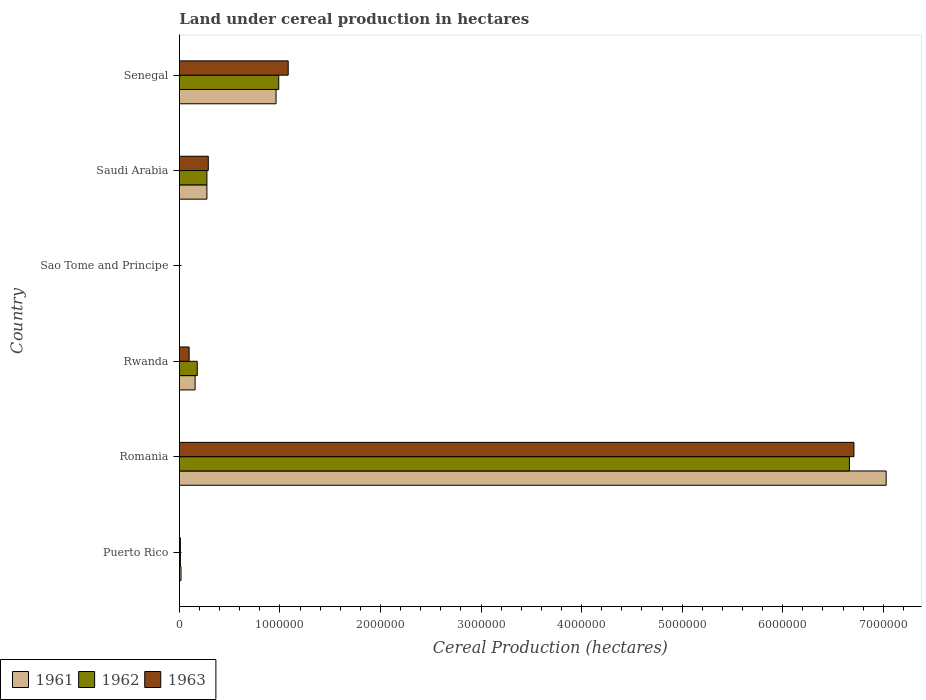Are the number of bars per tick equal to the number of legend labels?
Keep it short and to the point. Yes. What is the label of the 2nd group of bars from the top?
Make the answer very short. Saudi Arabia. What is the land under cereal production in 1962 in Puerto Rico?
Your response must be concise. 9489. Across all countries, what is the maximum land under cereal production in 1961?
Give a very brief answer. 7.03e+06. Across all countries, what is the minimum land under cereal production in 1962?
Provide a succinct answer. 270. In which country was the land under cereal production in 1963 maximum?
Your answer should be compact. Romania. In which country was the land under cereal production in 1961 minimum?
Provide a succinct answer. Sao Tome and Principe. What is the total land under cereal production in 1962 in the graph?
Keep it short and to the point. 8.11e+06. What is the difference between the land under cereal production in 1963 in Puerto Rico and that in Rwanda?
Provide a succinct answer. -8.71e+04. What is the difference between the land under cereal production in 1963 in Senegal and the land under cereal production in 1962 in Sao Tome and Principe?
Make the answer very short. 1.08e+06. What is the average land under cereal production in 1962 per country?
Your response must be concise. 1.35e+06. What is the difference between the land under cereal production in 1963 and land under cereal production in 1962 in Rwanda?
Your answer should be very brief. -8.09e+04. In how many countries, is the land under cereal production in 1963 greater than 6400000 hectares?
Offer a terse response. 1. What is the ratio of the land under cereal production in 1962 in Rwanda to that in Senegal?
Offer a terse response. 0.18. Is the difference between the land under cereal production in 1963 in Romania and Saudi Arabia greater than the difference between the land under cereal production in 1962 in Romania and Saudi Arabia?
Provide a short and direct response. Yes. What is the difference between the highest and the second highest land under cereal production in 1962?
Your response must be concise. 5.68e+06. What is the difference between the highest and the lowest land under cereal production in 1961?
Ensure brevity in your answer.  7.03e+06. What does the 2nd bar from the bottom in Saudi Arabia represents?
Offer a very short reply. 1962. How many bars are there?
Make the answer very short. 18. How many countries are there in the graph?
Offer a very short reply. 6. Does the graph contain any zero values?
Give a very brief answer. No. Where does the legend appear in the graph?
Keep it short and to the point. Bottom left. How are the legend labels stacked?
Your answer should be compact. Horizontal. What is the title of the graph?
Offer a very short reply. Land under cereal production in hectares. What is the label or title of the X-axis?
Keep it short and to the point. Cereal Production (hectares). What is the label or title of the Y-axis?
Your answer should be very brief. Country. What is the Cereal Production (hectares) of 1961 in Puerto Rico?
Make the answer very short. 1.59e+04. What is the Cereal Production (hectares) of 1962 in Puerto Rico?
Your answer should be very brief. 9489. What is the Cereal Production (hectares) in 1963 in Puerto Rico?
Your answer should be compact. 9519. What is the Cereal Production (hectares) in 1961 in Romania?
Provide a succinct answer. 7.03e+06. What is the Cereal Production (hectares) of 1962 in Romania?
Your answer should be very brief. 6.66e+06. What is the Cereal Production (hectares) in 1963 in Romania?
Keep it short and to the point. 6.71e+06. What is the Cereal Production (hectares) in 1961 in Rwanda?
Provide a short and direct response. 1.56e+05. What is the Cereal Production (hectares) in 1962 in Rwanda?
Ensure brevity in your answer.  1.78e+05. What is the Cereal Production (hectares) in 1963 in Rwanda?
Your answer should be compact. 9.66e+04. What is the Cereal Production (hectares) of 1961 in Sao Tome and Principe?
Offer a terse response. 270. What is the Cereal Production (hectares) in 1962 in Sao Tome and Principe?
Give a very brief answer. 270. What is the Cereal Production (hectares) of 1963 in Sao Tome and Principe?
Provide a short and direct response. 270. What is the Cereal Production (hectares) in 1961 in Saudi Arabia?
Make the answer very short. 2.74e+05. What is the Cereal Production (hectares) in 1962 in Saudi Arabia?
Your answer should be compact. 2.74e+05. What is the Cereal Production (hectares) in 1963 in Saudi Arabia?
Your response must be concise. 2.87e+05. What is the Cereal Production (hectares) in 1961 in Senegal?
Offer a very short reply. 9.61e+05. What is the Cereal Production (hectares) of 1962 in Senegal?
Your answer should be very brief. 9.88e+05. What is the Cereal Production (hectares) of 1963 in Senegal?
Provide a succinct answer. 1.08e+06. Across all countries, what is the maximum Cereal Production (hectares) of 1961?
Your response must be concise. 7.03e+06. Across all countries, what is the maximum Cereal Production (hectares) of 1962?
Keep it short and to the point. 6.66e+06. Across all countries, what is the maximum Cereal Production (hectares) of 1963?
Your answer should be very brief. 6.71e+06. Across all countries, what is the minimum Cereal Production (hectares) in 1961?
Offer a terse response. 270. Across all countries, what is the minimum Cereal Production (hectares) in 1962?
Keep it short and to the point. 270. Across all countries, what is the minimum Cereal Production (hectares) of 1963?
Provide a short and direct response. 270. What is the total Cereal Production (hectares) of 1961 in the graph?
Keep it short and to the point. 8.44e+06. What is the total Cereal Production (hectares) in 1962 in the graph?
Keep it short and to the point. 8.11e+06. What is the total Cereal Production (hectares) in 1963 in the graph?
Your response must be concise. 8.18e+06. What is the difference between the Cereal Production (hectares) of 1961 in Puerto Rico and that in Romania?
Ensure brevity in your answer.  -7.01e+06. What is the difference between the Cereal Production (hectares) in 1962 in Puerto Rico and that in Romania?
Your answer should be compact. -6.65e+06. What is the difference between the Cereal Production (hectares) of 1963 in Puerto Rico and that in Romania?
Keep it short and to the point. -6.70e+06. What is the difference between the Cereal Production (hectares) of 1961 in Puerto Rico and that in Rwanda?
Your answer should be very brief. -1.40e+05. What is the difference between the Cereal Production (hectares) of 1962 in Puerto Rico and that in Rwanda?
Offer a very short reply. -1.68e+05. What is the difference between the Cereal Production (hectares) of 1963 in Puerto Rico and that in Rwanda?
Keep it short and to the point. -8.71e+04. What is the difference between the Cereal Production (hectares) of 1961 in Puerto Rico and that in Sao Tome and Principe?
Keep it short and to the point. 1.56e+04. What is the difference between the Cereal Production (hectares) in 1962 in Puerto Rico and that in Sao Tome and Principe?
Ensure brevity in your answer.  9219. What is the difference between the Cereal Production (hectares) of 1963 in Puerto Rico and that in Sao Tome and Principe?
Your answer should be compact. 9249. What is the difference between the Cereal Production (hectares) in 1961 in Puerto Rico and that in Saudi Arabia?
Ensure brevity in your answer.  -2.58e+05. What is the difference between the Cereal Production (hectares) in 1962 in Puerto Rico and that in Saudi Arabia?
Provide a short and direct response. -2.64e+05. What is the difference between the Cereal Production (hectares) of 1963 in Puerto Rico and that in Saudi Arabia?
Offer a terse response. -2.78e+05. What is the difference between the Cereal Production (hectares) in 1961 in Puerto Rico and that in Senegal?
Make the answer very short. -9.45e+05. What is the difference between the Cereal Production (hectares) of 1962 in Puerto Rico and that in Senegal?
Keep it short and to the point. -9.79e+05. What is the difference between the Cereal Production (hectares) in 1963 in Puerto Rico and that in Senegal?
Give a very brief answer. -1.07e+06. What is the difference between the Cereal Production (hectares) of 1961 in Romania and that in Rwanda?
Keep it short and to the point. 6.87e+06. What is the difference between the Cereal Production (hectares) of 1962 in Romania and that in Rwanda?
Give a very brief answer. 6.49e+06. What is the difference between the Cereal Production (hectares) in 1963 in Romania and that in Rwanda?
Your answer should be compact. 6.61e+06. What is the difference between the Cereal Production (hectares) in 1961 in Romania and that in Sao Tome and Principe?
Ensure brevity in your answer.  7.03e+06. What is the difference between the Cereal Production (hectares) of 1962 in Romania and that in Sao Tome and Principe?
Offer a very short reply. 6.66e+06. What is the difference between the Cereal Production (hectares) of 1963 in Romania and that in Sao Tome and Principe?
Keep it short and to the point. 6.71e+06. What is the difference between the Cereal Production (hectares) of 1961 in Romania and that in Saudi Arabia?
Provide a short and direct response. 6.76e+06. What is the difference between the Cereal Production (hectares) in 1962 in Romania and that in Saudi Arabia?
Provide a short and direct response. 6.39e+06. What is the difference between the Cereal Production (hectares) in 1963 in Romania and that in Saudi Arabia?
Your answer should be compact. 6.42e+06. What is the difference between the Cereal Production (hectares) in 1961 in Romania and that in Senegal?
Offer a terse response. 6.07e+06. What is the difference between the Cereal Production (hectares) in 1962 in Romania and that in Senegal?
Offer a very short reply. 5.68e+06. What is the difference between the Cereal Production (hectares) in 1963 in Romania and that in Senegal?
Offer a terse response. 5.63e+06. What is the difference between the Cereal Production (hectares) in 1961 in Rwanda and that in Sao Tome and Principe?
Your answer should be compact. 1.56e+05. What is the difference between the Cereal Production (hectares) in 1962 in Rwanda and that in Sao Tome and Principe?
Your answer should be very brief. 1.77e+05. What is the difference between the Cereal Production (hectares) of 1963 in Rwanda and that in Sao Tome and Principe?
Make the answer very short. 9.64e+04. What is the difference between the Cereal Production (hectares) of 1961 in Rwanda and that in Saudi Arabia?
Keep it short and to the point. -1.17e+05. What is the difference between the Cereal Production (hectares) of 1962 in Rwanda and that in Saudi Arabia?
Your response must be concise. -9.61e+04. What is the difference between the Cereal Production (hectares) in 1963 in Rwanda and that in Saudi Arabia?
Offer a terse response. -1.91e+05. What is the difference between the Cereal Production (hectares) of 1961 in Rwanda and that in Senegal?
Your response must be concise. -8.05e+05. What is the difference between the Cereal Production (hectares) of 1962 in Rwanda and that in Senegal?
Ensure brevity in your answer.  -8.10e+05. What is the difference between the Cereal Production (hectares) of 1963 in Rwanda and that in Senegal?
Give a very brief answer. -9.85e+05. What is the difference between the Cereal Production (hectares) in 1961 in Sao Tome and Principe and that in Saudi Arabia?
Your answer should be compact. -2.73e+05. What is the difference between the Cereal Production (hectares) of 1962 in Sao Tome and Principe and that in Saudi Arabia?
Provide a succinct answer. -2.73e+05. What is the difference between the Cereal Production (hectares) in 1963 in Sao Tome and Principe and that in Saudi Arabia?
Provide a short and direct response. -2.87e+05. What is the difference between the Cereal Production (hectares) in 1961 in Sao Tome and Principe and that in Senegal?
Offer a terse response. -9.61e+05. What is the difference between the Cereal Production (hectares) in 1962 in Sao Tome and Principe and that in Senegal?
Provide a short and direct response. -9.88e+05. What is the difference between the Cereal Production (hectares) of 1963 in Sao Tome and Principe and that in Senegal?
Your answer should be compact. -1.08e+06. What is the difference between the Cereal Production (hectares) of 1961 in Saudi Arabia and that in Senegal?
Make the answer very short. -6.88e+05. What is the difference between the Cereal Production (hectares) of 1962 in Saudi Arabia and that in Senegal?
Give a very brief answer. -7.14e+05. What is the difference between the Cereal Production (hectares) of 1963 in Saudi Arabia and that in Senegal?
Offer a terse response. -7.95e+05. What is the difference between the Cereal Production (hectares) of 1961 in Puerto Rico and the Cereal Production (hectares) of 1962 in Romania?
Provide a short and direct response. -6.65e+06. What is the difference between the Cereal Production (hectares) in 1961 in Puerto Rico and the Cereal Production (hectares) in 1963 in Romania?
Give a very brief answer. -6.69e+06. What is the difference between the Cereal Production (hectares) in 1962 in Puerto Rico and the Cereal Production (hectares) in 1963 in Romania?
Make the answer very short. -6.70e+06. What is the difference between the Cereal Production (hectares) in 1961 in Puerto Rico and the Cereal Production (hectares) in 1962 in Rwanda?
Your answer should be very brief. -1.62e+05. What is the difference between the Cereal Production (hectares) of 1961 in Puerto Rico and the Cereal Production (hectares) of 1963 in Rwanda?
Make the answer very short. -8.08e+04. What is the difference between the Cereal Production (hectares) of 1962 in Puerto Rico and the Cereal Production (hectares) of 1963 in Rwanda?
Ensure brevity in your answer.  -8.72e+04. What is the difference between the Cereal Production (hectares) of 1961 in Puerto Rico and the Cereal Production (hectares) of 1962 in Sao Tome and Principe?
Provide a short and direct response. 1.56e+04. What is the difference between the Cereal Production (hectares) in 1961 in Puerto Rico and the Cereal Production (hectares) in 1963 in Sao Tome and Principe?
Offer a very short reply. 1.56e+04. What is the difference between the Cereal Production (hectares) of 1962 in Puerto Rico and the Cereal Production (hectares) of 1963 in Sao Tome and Principe?
Provide a succinct answer. 9219. What is the difference between the Cereal Production (hectares) in 1961 in Puerto Rico and the Cereal Production (hectares) in 1962 in Saudi Arabia?
Give a very brief answer. -2.58e+05. What is the difference between the Cereal Production (hectares) in 1961 in Puerto Rico and the Cereal Production (hectares) in 1963 in Saudi Arabia?
Offer a terse response. -2.71e+05. What is the difference between the Cereal Production (hectares) in 1962 in Puerto Rico and the Cereal Production (hectares) in 1963 in Saudi Arabia?
Your answer should be very brief. -2.78e+05. What is the difference between the Cereal Production (hectares) in 1961 in Puerto Rico and the Cereal Production (hectares) in 1962 in Senegal?
Offer a terse response. -9.72e+05. What is the difference between the Cereal Production (hectares) of 1961 in Puerto Rico and the Cereal Production (hectares) of 1963 in Senegal?
Ensure brevity in your answer.  -1.07e+06. What is the difference between the Cereal Production (hectares) in 1962 in Puerto Rico and the Cereal Production (hectares) in 1963 in Senegal?
Offer a very short reply. -1.07e+06. What is the difference between the Cereal Production (hectares) in 1961 in Romania and the Cereal Production (hectares) in 1962 in Rwanda?
Offer a very short reply. 6.85e+06. What is the difference between the Cereal Production (hectares) in 1961 in Romania and the Cereal Production (hectares) in 1963 in Rwanda?
Your response must be concise. 6.93e+06. What is the difference between the Cereal Production (hectares) in 1962 in Romania and the Cereal Production (hectares) in 1963 in Rwanda?
Offer a terse response. 6.57e+06. What is the difference between the Cereal Production (hectares) in 1961 in Romania and the Cereal Production (hectares) in 1962 in Sao Tome and Principe?
Give a very brief answer. 7.03e+06. What is the difference between the Cereal Production (hectares) in 1961 in Romania and the Cereal Production (hectares) in 1963 in Sao Tome and Principe?
Offer a terse response. 7.03e+06. What is the difference between the Cereal Production (hectares) of 1962 in Romania and the Cereal Production (hectares) of 1963 in Sao Tome and Principe?
Provide a succinct answer. 6.66e+06. What is the difference between the Cereal Production (hectares) in 1961 in Romania and the Cereal Production (hectares) in 1962 in Saudi Arabia?
Provide a succinct answer. 6.76e+06. What is the difference between the Cereal Production (hectares) of 1961 in Romania and the Cereal Production (hectares) of 1963 in Saudi Arabia?
Provide a short and direct response. 6.74e+06. What is the difference between the Cereal Production (hectares) of 1962 in Romania and the Cereal Production (hectares) of 1963 in Saudi Arabia?
Give a very brief answer. 6.38e+06. What is the difference between the Cereal Production (hectares) of 1961 in Romania and the Cereal Production (hectares) of 1962 in Senegal?
Provide a succinct answer. 6.04e+06. What is the difference between the Cereal Production (hectares) of 1961 in Romania and the Cereal Production (hectares) of 1963 in Senegal?
Your response must be concise. 5.95e+06. What is the difference between the Cereal Production (hectares) in 1962 in Romania and the Cereal Production (hectares) in 1963 in Senegal?
Your response must be concise. 5.58e+06. What is the difference between the Cereal Production (hectares) in 1961 in Rwanda and the Cereal Production (hectares) in 1962 in Sao Tome and Principe?
Make the answer very short. 1.56e+05. What is the difference between the Cereal Production (hectares) in 1961 in Rwanda and the Cereal Production (hectares) in 1963 in Sao Tome and Principe?
Offer a terse response. 1.56e+05. What is the difference between the Cereal Production (hectares) in 1962 in Rwanda and the Cereal Production (hectares) in 1963 in Sao Tome and Principe?
Offer a very short reply. 1.77e+05. What is the difference between the Cereal Production (hectares) in 1961 in Rwanda and the Cereal Production (hectares) in 1962 in Saudi Arabia?
Make the answer very short. -1.18e+05. What is the difference between the Cereal Production (hectares) in 1961 in Rwanda and the Cereal Production (hectares) in 1963 in Saudi Arabia?
Offer a terse response. -1.31e+05. What is the difference between the Cereal Production (hectares) of 1962 in Rwanda and the Cereal Production (hectares) of 1963 in Saudi Arabia?
Make the answer very short. -1.10e+05. What is the difference between the Cereal Production (hectares) in 1961 in Rwanda and the Cereal Production (hectares) in 1962 in Senegal?
Offer a terse response. -8.32e+05. What is the difference between the Cereal Production (hectares) of 1961 in Rwanda and the Cereal Production (hectares) of 1963 in Senegal?
Provide a short and direct response. -9.26e+05. What is the difference between the Cereal Production (hectares) in 1962 in Rwanda and the Cereal Production (hectares) in 1963 in Senegal?
Your answer should be compact. -9.04e+05. What is the difference between the Cereal Production (hectares) of 1961 in Sao Tome and Principe and the Cereal Production (hectares) of 1962 in Saudi Arabia?
Keep it short and to the point. -2.73e+05. What is the difference between the Cereal Production (hectares) of 1961 in Sao Tome and Principe and the Cereal Production (hectares) of 1963 in Saudi Arabia?
Provide a succinct answer. -2.87e+05. What is the difference between the Cereal Production (hectares) in 1962 in Sao Tome and Principe and the Cereal Production (hectares) in 1963 in Saudi Arabia?
Give a very brief answer. -2.87e+05. What is the difference between the Cereal Production (hectares) of 1961 in Sao Tome and Principe and the Cereal Production (hectares) of 1962 in Senegal?
Offer a very short reply. -9.88e+05. What is the difference between the Cereal Production (hectares) in 1961 in Sao Tome and Principe and the Cereal Production (hectares) in 1963 in Senegal?
Offer a very short reply. -1.08e+06. What is the difference between the Cereal Production (hectares) in 1962 in Sao Tome and Principe and the Cereal Production (hectares) in 1963 in Senegal?
Give a very brief answer. -1.08e+06. What is the difference between the Cereal Production (hectares) in 1961 in Saudi Arabia and the Cereal Production (hectares) in 1962 in Senegal?
Your answer should be very brief. -7.14e+05. What is the difference between the Cereal Production (hectares) in 1961 in Saudi Arabia and the Cereal Production (hectares) in 1963 in Senegal?
Make the answer very short. -8.08e+05. What is the difference between the Cereal Production (hectares) in 1962 in Saudi Arabia and the Cereal Production (hectares) in 1963 in Senegal?
Your response must be concise. -8.08e+05. What is the average Cereal Production (hectares) in 1961 per country?
Offer a very short reply. 1.41e+06. What is the average Cereal Production (hectares) in 1962 per country?
Ensure brevity in your answer.  1.35e+06. What is the average Cereal Production (hectares) in 1963 per country?
Your response must be concise. 1.36e+06. What is the difference between the Cereal Production (hectares) of 1961 and Cereal Production (hectares) of 1962 in Puerto Rico?
Offer a very short reply. 6383. What is the difference between the Cereal Production (hectares) in 1961 and Cereal Production (hectares) in 1963 in Puerto Rico?
Provide a short and direct response. 6353. What is the difference between the Cereal Production (hectares) of 1962 and Cereal Production (hectares) of 1963 in Puerto Rico?
Ensure brevity in your answer.  -30. What is the difference between the Cereal Production (hectares) of 1961 and Cereal Production (hectares) of 1962 in Romania?
Keep it short and to the point. 3.65e+05. What is the difference between the Cereal Production (hectares) in 1961 and Cereal Production (hectares) in 1963 in Romania?
Provide a succinct answer. 3.20e+05. What is the difference between the Cereal Production (hectares) of 1962 and Cereal Production (hectares) of 1963 in Romania?
Provide a short and direct response. -4.51e+04. What is the difference between the Cereal Production (hectares) in 1961 and Cereal Production (hectares) in 1962 in Rwanda?
Your answer should be compact. -2.15e+04. What is the difference between the Cereal Production (hectares) in 1961 and Cereal Production (hectares) in 1963 in Rwanda?
Provide a short and direct response. 5.94e+04. What is the difference between the Cereal Production (hectares) of 1962 and Cereal Production (hectares) of 1963 in Rwanda?
Make the answer very short. 8.09e+04. What is the difference between the Cereal Production (hectares) of 1961 and Cereal Production (hectares) of 1963 in Sao Tome and Principe?
Offer a very short reply. 0. What is the difference between the Cereal Production (hectares) of 1961 and Cereal Production (hectares) of 1962 in Saudi Arabia?
Your answer should be compact. -100. What is the difference between the Cereal Production (hectares) in 1961 and Cereal Production (hectares) in 1963 in Saudi Arabia?
Ensure brevity in your answer.  -1.38e+04. What is the difference between the Cereal Production (hectares) of 1962 and Cereal Production (hectares) of 1963 in Saudi Arabia?
Give a very brief answer. -1.37e+04. What is the difference between the Cereal Production (hectares) in 1961 and Cereal Production (hectares) in 1962 in Senegal?
Give a very brief answer. -2.68e+04. What is the difference between the Cereal Production (hectares) of 1961 and Cereal Production (hectares) of 1963 in Senegal?
Give a very brief answer. -1.21e+05. What is the difference between the Cereal Production (hectares) in 1962 and Cereal Production (hectares) in 1963 in Senegal?
Keep it short and to the point. -9.40e+04. What is the ratio of the Cereal Production (hectares) in 1961 in Puerto Rico to that in Romania?
Your answer should be compact. 0. What is the ratio of the Cereal Production (hectares) in 1962 in Puerto Rico to that in Romania?
Provide a short and direct response. 0. What is the ratio of the Cereal Production (hectares) of 1963 in Puerto Rico to that in Romania?
Your answer should be very brief. 0. What is the ratio of the Cereal Production (hectares) of 1961 in Puerto Rico to that in Rwanda?
Your answer should be compact. 0.1. What is the ratio of the Cereal Production (hectares) of 1962 in Puerto Rico to that in Rwanda?
Your answer should be compact. 0.05. What is the ratio of the Cereal Production (hectares) of 1963 in Puerto Rico to that in Rwanda?
Your answer should be compact. 0.1. What is the ratio of the Cereal Production (hectares) in 1961 in Puerto Rico to that in Sao Tome and Principe?
Make the answer very short. 58.79. What is the ratio of the Cereal Production (hectares) of 1962 in Puerto Rico to that in Sao Tome and Principe?
Your answer should be very brief. 35.14. What is the ratio of the Cereal Production (hectares) in 1963 in Puerto Rico to that in Sao Tome and Principe?
Keep it short and to the point. 35.26. What is the ratio of the Cereal Production (hectares) of 1961 in Puerto Rico to that in Saudi Arabia?
Offer a very short reply. 0.06. What is the ratio of the Cereal Production (hectares) in 1962 in Puerto Rico to that in Saudi Arabia?
Provide a succinct answer. 0.03. What is the ratio of the Cereal Production (hectares) of 1963 in Puerto Rico to that in Saudi Arabia?
Ensure brevity in your answer.  0.03. What is the ratio of the Cereal Production (hectares) of 1961 in Puerto Rico to that in Senegal?
Offer a very short reply. 0.02. What is the ratio of the Cereal Production (hectares) in 1962 in Puerto Rico to that in Senegal?
Provide a succinct answer. 0.01. What is the ratio of the Cereal Production (hectares) in 1963 in Puerto Rico to that in Senegal?
Provide a short and direct response. 0.01. What is the ratio of the Cereal Production (hectares) of 1961 in Romania to that in Rwanda?
Your answer should be compact. 45.04. What is the ratio of the Cereal Production (hectares) of 1962 in Romania to that in Rwanda?
Offer a very short reply. 37.53. What is the ratio of the Cereal Production (hectares) of 1963 in Romania to that in Rwanda?
Offer a very short reply. 69.42. What is the ratio of the Cereal Production (hectares) of 1961 in Romania to that in Sao Tome and Principe?
Your answer should be very brief. 2.60e+04. What is the ratio of the Cereal Production (hectares) of 1962 in Romania to that in Sao Tome and Principe?
Provide a succinct answer. 2.47e+04. What is the ratio of the Cereal Production (hectares) of 1963 in Romania to that in Sao Tome and Principe?
Offer a terse response. 2.48e+04. What is the ratio of the Cereal Production (hectares) of 1961 in Romania to that in Saudi Arabia?
Keep it short and to the point. 25.7. What is the ratio of the Cereal Production (hectares) in 1962 in Romania to that in Saudi Arabia?
Your answer should be compact. 24.36. What is the ratio of the Cereal Production (hectares) of 1963 in Romania to that in Saudi Arabia?
Offer a very short reply. 23.35. What is the ratio of the Cereal Production (hectares) in 1961 in Romania to that in Senegal?
Make the answer very short. 7.31. What is the ratio of the Cereal Production (hectares) of 1962 in Romania to that in Senegal?
Provide a short and direct response. 6.74. What is the ratio of the Cereal Production (hectares) of 1963 in Romania to that in Senegal?
Offer a terse response. 6.2. What is the ratio of the Cereal Production (hectares) in 1961 in Rwanda to that in Sao Tome and Principe?
Provide a short and direct response. 578.07. What is the ratio of the Cereal Production (hectares) in 1962 in Rwanda to that in Sao Tome and Principe?
Offer a very short reply. 657.55. What is the ratio of the Cereal Production (hectares) in 1963 in Rwanda to that in Sao Tome and Principe?
Provide a short and direct response. 357.94. What is the ratio of the Cereal Production (hectares) in 1961 in Rwanda to that in Saudi Arabia?
Give a very brief answer. 0.57. What is the ratio of the Cereal Production (hectares) of 1962 in Rwanda to that in Saudi Arabia?
Provide a succinct answer. 0.65. What is the ratio of the Cereal Production (hectares) of 1963 in Rwanda to that in Saudi Arabia?
Ensure brevity in your answer.  0.34. What is the ratio of the Cereal Production (hectares) of 1961 in Rwanda to that in Senegal?
Give a very brief answer. 0.16. What is the ratio of the Cereal Production (hectares) of 1962 in Rwanda to that in Senegal?
Your answer should be very brief. 0.18. What is the ratio of the Cereal Production (hectares) of 1963 in Rwanda to that in Senegal?
Provide a short and direct response. 0.09. What is the ratio of the Cereal Production (hectares) of 1963 in Sao Tome and Principe to that in Saudi Arabia?
Your response must be concise. 0. What is the ratio of the Cereal Production (hectares) of 1961 in Sao Tome and Principe to that in Senegal?
Keep it short and to the point. 0. What is the ratio of the Cereal Production (hectares) in 1962 in Sao Tome and Principe to that in Senegal?
Ensure brevity in your answer.  0. What is the ratio of the Cereal Production (hectares) in 1963 in Sao Tome and Principe to that in Senegal?
Ensure brevity in your answer.  0. What is the ratio of the Cereal Production (hectares) in 1961 in Saudi Arabia to that in Senegal?
Provide a short and direct response. 0.28. What is the ratio of the Cereal Production (hectares) in 1962 in Saudi Arabia to that in Senegal?
Provide a short and direct response. 0.28. What is the ratio of the Cereal Production (hectares) in 1963 in Saudi Arabia to that in Senegal?
Your answer should be compact. 0.27. What is the difference between the highest and the second highest Cereal Production (hectares) of 1961?
Provide a short and direct response. 6.07e+06. What is the difference between the highest and the second highest Cereal Production (hectares) in 1962?
Your answer should be very brief. 5.68e+06. What is the difference between the highest and the second highest Cereal Production (hectares) of 1963?
Your response must be concise. 5.63e+06. What is the difference between the highest and the lowest Cereal Production (hectares) in 1961?
Give a very brief answer. 7.03e+06. What is the difference between the highest and the lowest Cereal Production (hectares) in 1962?
Provide a short and direct response. 6.66e+06. What is the difference between the highest and the lowest Cereal Production (hectares) of 1963?
Offer a very short reply. 6.71e+06. 